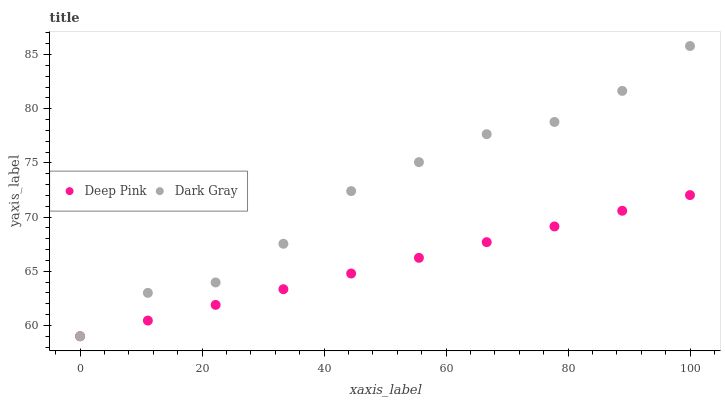Does Deep Pink have the minimum area under the curve?
Answer yes or no. Yes. Does Dark Gray have the maximum area under the curve?
Answer yes or no. Yes. Does Deep Pink have the maximum area under the curve?
Answer yes or no. No. Is Deep Pink the smoothest?
Answer yes or no. Yes. Is Dark Gray the roughest?
Answer yes or no. Yes. Is Deep Pink the roughest?
Answer yes or no. No. Does Dark Gray have the lowest value?
Answer yes or no. Yes. Does Dark Gray have the highest value?
Answer yes or no. Yes. Does Deep Pink have the highest value?
Answer yes or no. No. Does Deep Pink intersect Dark Gray?
Answer yes or no. Yes. Is Deep Pink less than Dark Gray?
Answer yes or no. No. Is Deep Pink greater than Dark Gray?
Answer yes or no. No. 